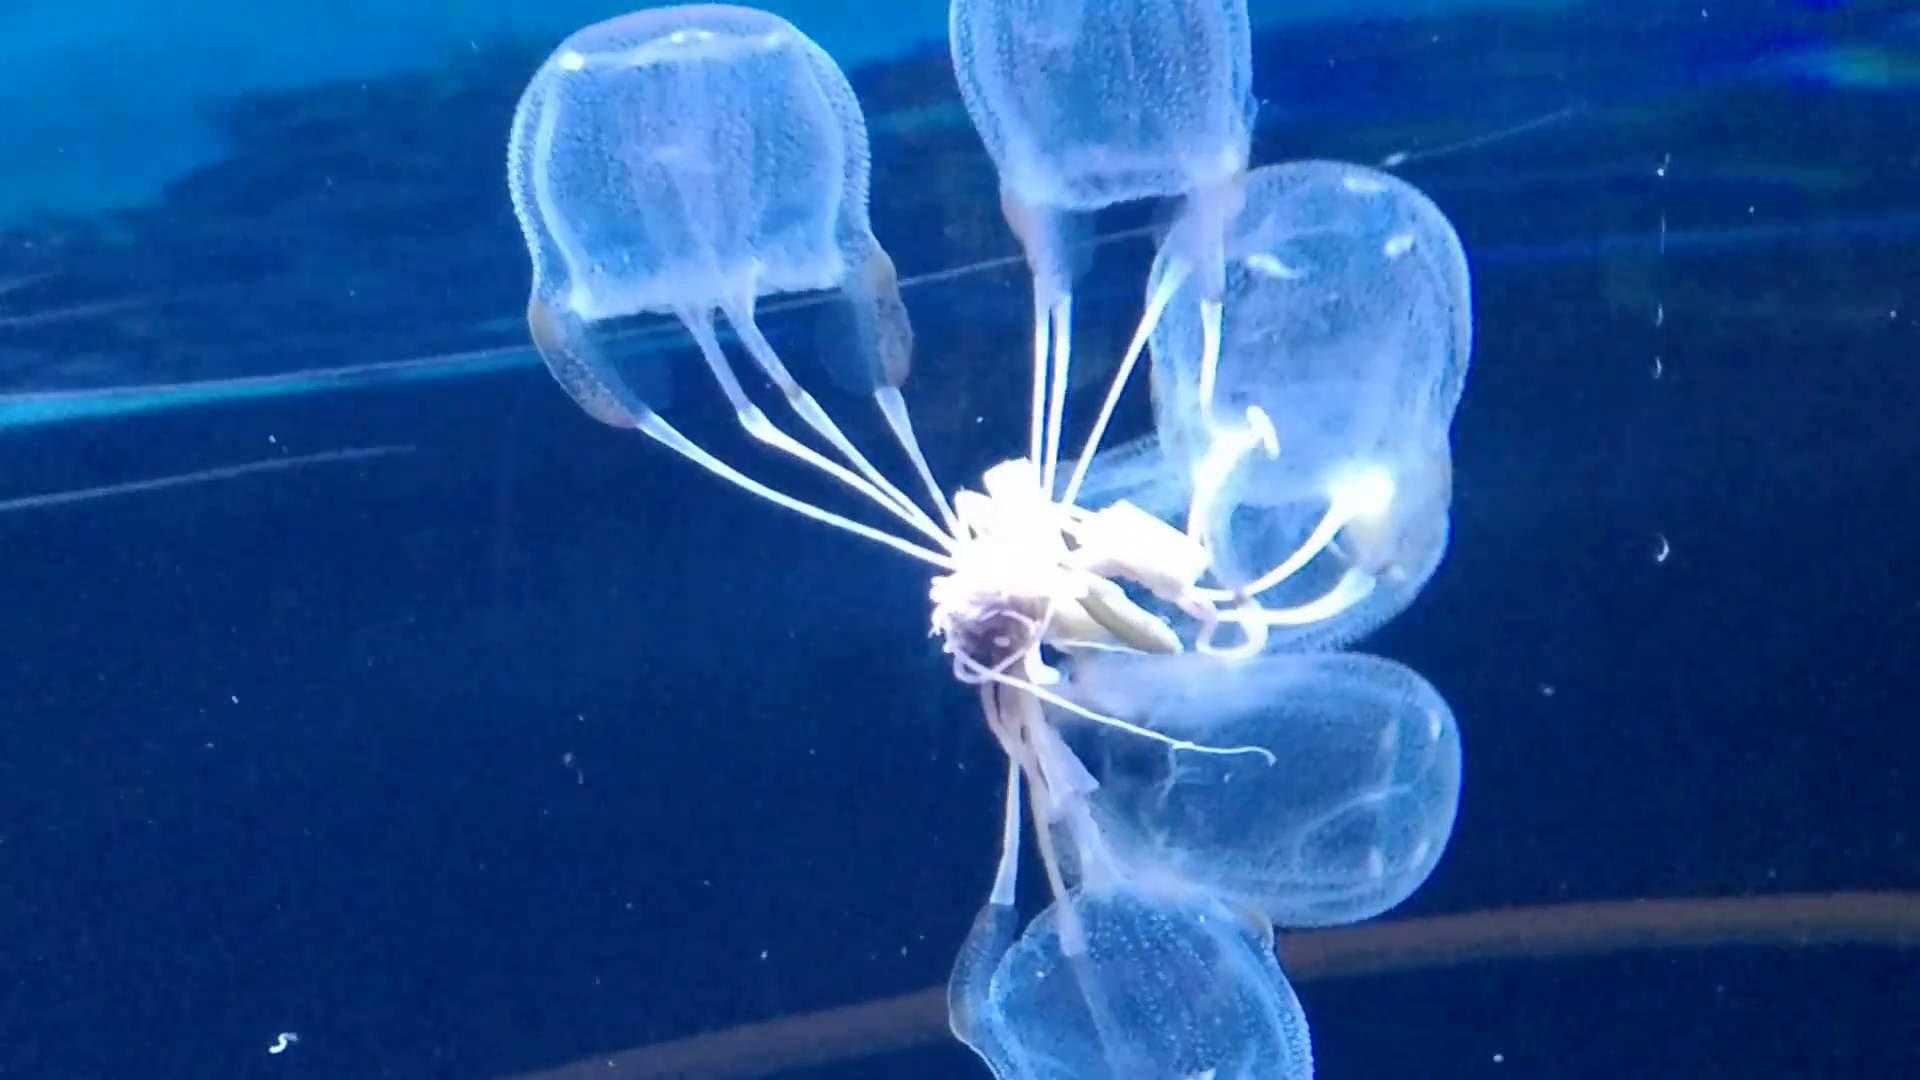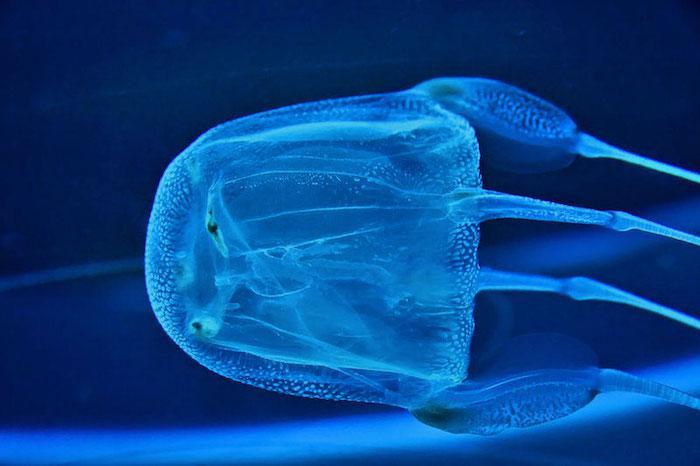The first image is the image on the left, the second image is the image on the right. For the images shown, is this caption "All jellyfish have translucent glowing bluish bodies, and all trail slender tendrils." true? Answer yes or no. Yes. The first image is the image on the left, the second image is the image on the right. Evaluate the accuracy of this statement regarding the images: "There are multiple jellyfish in the image on the left.". Is it true? Answer yes or no. Yes. 